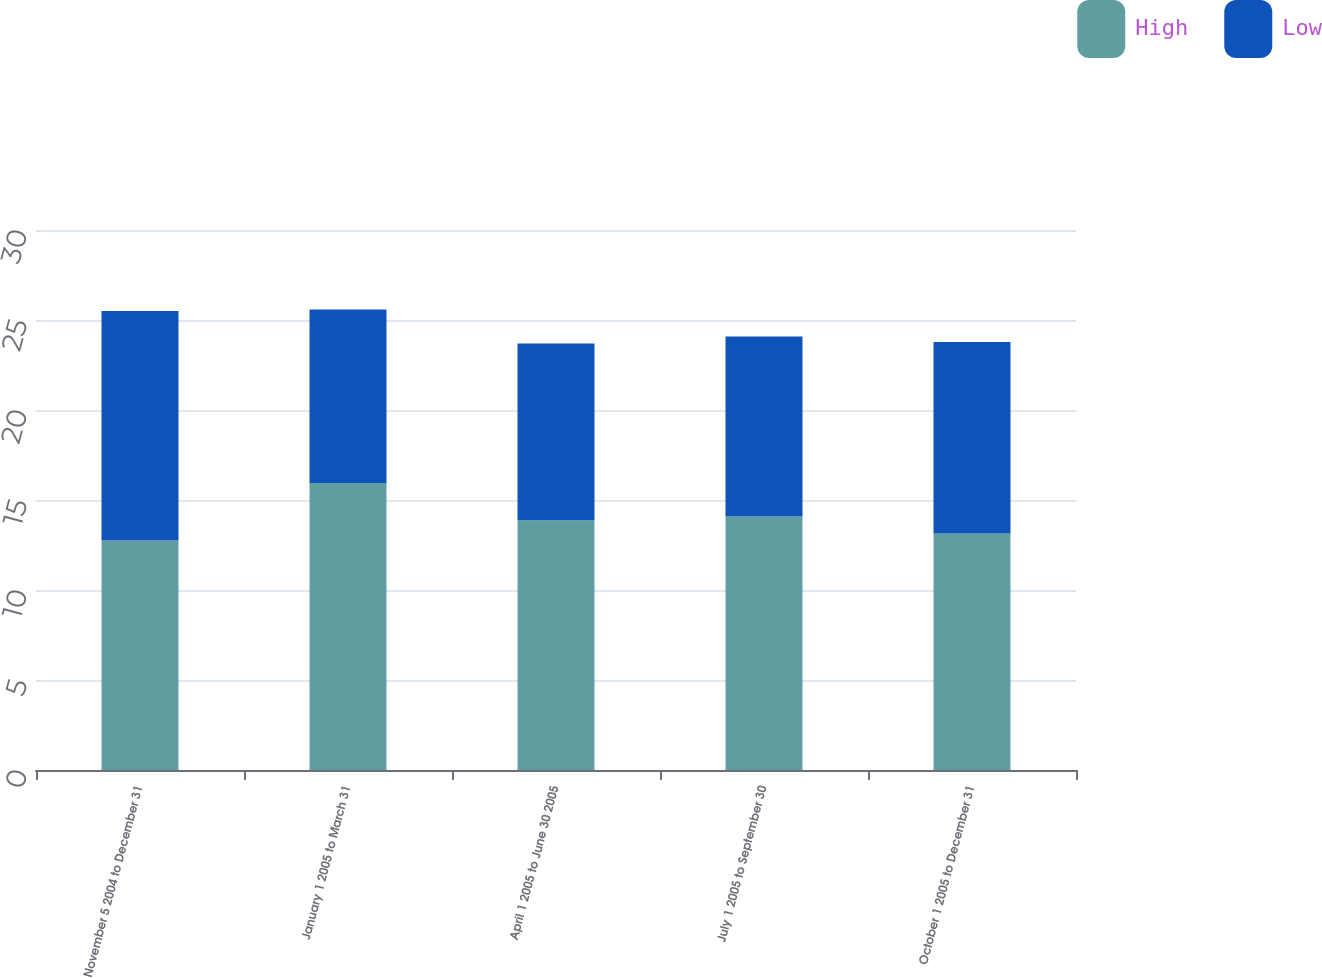Convert chart. <chart><loc_0><loc_0><loc_500><loc_500><stacked_bar_chart><ecel><fcel>November 5 2004 to December 31<fcel>January 1 2005 to March 31<fcel>April 1 2005 to June 30 2005<fcel>July 1 2005 to September 30<fcel>October 1 2005 to December 31<nl><fcel>High<fcel>12.75<fcel>15.95<fcel>13.87<fcel>14.09<fcel>13.14<nl><fcel>Low<fcel>12.75<fcel>9.64<fcel>9.83<fcel>9.99<fcel>10.64<nl></chart> 